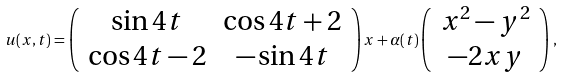Convert formula to latex. <formula><loc_0><loc_0><loc_500><loc_500>u ( x , t ) = \left ( \begin{array} { c c } \sin 4 t & \cos 4 t + 2 \\ \cos 4 t - 2 & - \sin 4 t \end{array} \right ) x + \alpha ( t ) \left ( \begin{array} { c } x ^ { 2 } - y ^ { 2 } \\ - 2 x y \end{array} \right ) ,</formula> 